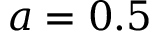<formula> <loc_0><loc_0><loc_500><loc_500>a = 0 . 5</formula> 